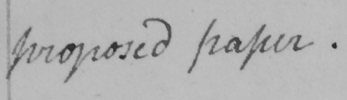What is written in this line of handwriting? proposed paper . 